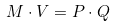<formula> <loc_0><loc_0><loc_500><loc_500>M \cdot V = P \cdot Q</formula> 